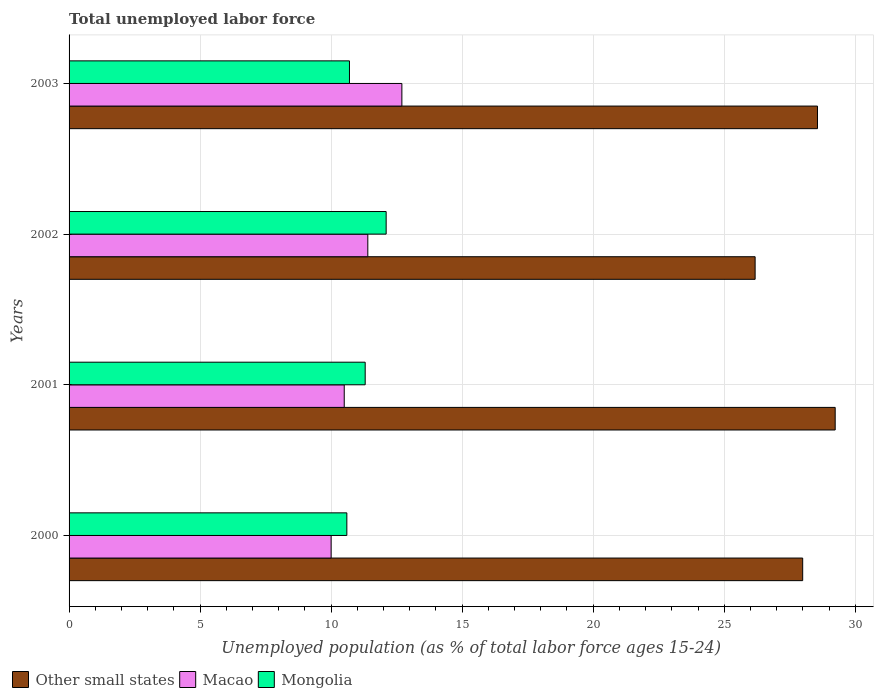Are the number of bars per tick equal to the number of legend labels?
Provide a short and direct response. Yes. Are the number of bars on each tick of the Y-axis equal?
Keep it short and to the point. Yes. How many bars are there on the 1st tick from the bottom?
Make the answer very short. 3. In how many cases, is the number of bars for a given year not equal to the number of legend labels?
Your answer should be very brief. 0. Across all years, what is the maximum percentage of unemployed population in in Other small states?
Your response must be concise. 29.23. Across all years, what is the minimum percentage of unemployed population in in Other small states?
Ensure brevity in your answer.  26.18. In which year was the percentage of unemployed population in in Mongolia minimum?
Offer a terse response. 2000. What is the total percentage of unemployed population in in Mongolia in the graph?
Give a very brief answer. 44.7. What is the difference between the percentage of unemployed population in in Macao in 2000 and that in 2003?
Provide a succinct answer. -2.7. What is the difference between the percentage of unemployed population in in Mongolia in 2001 and the percentage of unemployed population in in Macao in 2003?
Offer a terse response. -1.4. What is the average percentage of unemployed population in in Mongolia per year?
Provide a succinct answer. 11.18. In the year 2003, what is the difference between the percentage of unemployed population in in Mongolia and percentage of unemployed population in in Macao?
Ensure brevity in your answer.  -2. What is the ratio of the percentage of unemployed population in in Other small states in 2001 to that in 2003?
Ensure brevity in your answer.  1.02. Is the percentage of unemployed population in in Mongolia in 2000 less than that in 2003?
Provide a succinct answer. Yes. Is the difference between the percentage of unemployed population in in Mongolia in 2001 and 2003 greater than the difference between the percentage of unemployed population in in Macao in 2001 and 2003?
Offer a very short reply. Yes. What is the difference between the highest and the second highest percentage of unemployed population in in Macao?
Ensure brevity in your answer.  1.3. What is the difference between the highest and the lowest percentage of unemployed population in in Other small states?
Make the answer very short. 3.06. In how many years, is the percentage of unemployed population in in Other small states greater than the average percentage of unemployed population in in Other small states taken over all years?
Provide a succinct answer. 3. What does the 2nd bar from the top in 2003 represents?
Make the answer very short. Macao. What does the 1st bar from the bottom in 2002 represents?
Make the answer very short. Other small states. Is it the case that in every year, the sum of the percentage of unemployed population in in Mongolia and percentage of unemployed population in in Macao is greater than the percentage of unemployed population in in Other small states?
Provide a short and direct response. No. Where does the legend appear in the graph?
Offer a very short reply. Bottom left. How many legend labels are there?
Your answer should be compact. 3. What is the title of the graph?
Provide a succinct answer. Total unemployed labor force. Does "Australia" appear as one of the legend labels in the graph?
Ensure brevity in your answer.  No. What is the label or title of the X-axis?
Offer a very short reply. Unemployed population (as % of total labor force ages 15-24). What is the label or title of the Y-axis?
Your response must be concise. Years. What is the Unemployed population (as % of total labor force ages 15-24) in Other small states in 2000?
Your answer should be compact. 27.99. What is the Unemployed population (as % of total labor force ages 15-24) of Mongolia in 2000?
Offer a terse response. 10.6. What is the Unemployed population (as % of total labor force ages 15-24) of Other small states in 2001?
Give a very brief answer. 29.23. What is the Unemployed population (as % of total labor force ages 15-24) of Macao in 2001?
Your answer should be very brief. 10.5. What is the Unemployed population (as % of total labor force ages 15-24) of Mongolia in 2001?
Ensure brevity in your answer.  11.3. What is the Unemployed population (as % of total labor force ages 15-24) of Other small states in 2002?
Provide a succinct answer. 26.18. What is the Unemployed population (as % of total labor force ages 15-24) in Macao in 2002?
Ensure brevity in your answer.  11.4. What is the Unemployed population (as % of total labor force ages 15-24) in Mongolia in 2002?
Provide a succinct answer. 12.1. What is the Unemployed population (as % of total labor force ages 15-24) in Other small states in 2003?
Give a very brief answer. 28.56. What is the Unemployed population (as % of total labor force ages 15-24) of Macao in 2003?
Ensure brevity in your answer.  12.7. What is the Unemployed population (as % of total labor force ages 15-24) of Mongolia in 2003?
Your answer should be compact. 10.7. Across all years, what is the maximum Unemployed population (as % of total labor force ages 15-24) of Other small states?
Provide a succinct answer. 29.23. Across all years, what is the maximum Unemployed population (as % of total labor force ages 15-24) of Macao?
Your answer should be compact. 12.7. Across all years, what is the maximum Unemployed population (as % of total labor force ages 15-24) of Mongolia?
Provide a succinct answer. 12.1. Across all years, what is the minimum Unemployed population (as % of total labor force ages 15-24) of Other small states?
Ensure brevity in your answer.  26.18. Across all years, what is the minimum Unemployed population (as % of total labor force ages 15-24) in Mongolia?
Offer a terse response. 10.6. What is the total Unemployed population (as % of total labor force ages 15-24) in Other small states in the graph?
Ensure brevity in your answer.  111.97. What is the total Unemployed population (as % of total labor force ages 15-24) of Macao in the graph?
Make the answer very short. 44.6. What is the total Unemployed population (as % of total labor force ages 15-24) of Mongolia in the graph?
Offer a terse response. 44.7. What is the difference between the Unemployed population (as % of total labor force ages 15-24) of Other small states in 2000 and that in 2001?
Your answer should be very brief. -1.24. What is the difference between the Unemployed population (as % of total labor force ages 15-24) of Mongolia in 2000 and that in 2001?
Your answer should be very brief. -0.7. What is the difference between the Unemployed population (as % of total labor force ages 15-24) in Other small states in 2000 and that in 2002?
Offer a very short reply. 1.81. What is the difference between the Unemployed population (as % of total labor force ages 15-24) in Mongolia in 2000 and that in 2002?
Your response must be concise. -1.5. What is the difference between the Unemployed population (as % of total labor force ages 15-24) in Other small states in 2000 and that in 2003?
Ensure brevity in your answer.  -0.56. What is the difference between the Unemployed population (as % of total labor force ages 15-24) in Mongolia in 2000 and that in 2003?
Give a very brief answer. -0.1. What is the difference between the Unemployed population (as % of total labor force ages 15-24) in Other small states in 2001 and that in 2002?
Provide a succinct answer. 3.06. What is the difference between the Unemployed population (as % of total labor force ages 15-24) of Mongolia in 2001 and that in 2002?
Offer a terse response. -0.8. What is the difference between the Unemployed population (as % of total labor force ages 15-24) of Other small states in 2001 and that in 2003?
Give a very brief answer. 0.68. What is the difference between the Unemployed population (as % of total labor force ages 15-24) of Macao in 2001 and that in 2003?
Provide a short and direct response. -2.2. What is the difference between the Unemployed population (as % of total labor force ages 15-24) in Other small states in 2002 and that in 2003?
Your answer should be compact. -2.38. What is the difference between the Unemployed population (as % of total labor force ages 15-24) of Other small states in 2000 and the Unemployed population (as % of total labor force ages 15-24) of Macao in 2001?
Provide a succinct answer. 17.49. What is the difference between the Unemployed population (as % of total labor force ages 15-24) in Other small states in 2000 and the Unemployed population (as % of total labor force ages 15-24) in Mongolia in 2001?
Give a very brief answer. 16.69. What is the difference between the Unemployed population (as % of total labor force ages 15-24) in Other small states in 2000 and the Unemployed population (as % of total labor force ages 15-24) in Macao in 2002?
Your response must be concise. 16.59. What is the difference between the Unemployed population (as % of total labor force ages 15-24) of Other small states in 2000 and the Unemployed population (as % of total labor force ages 15-24) of Mongolia in 2002?
Provide a succinct answer. 15.89. What is the difference between the Unemployed population (as % of total labor force ages 15-24) of Other small states in 2000 and the Unemployed population (as % of total labor force ages 15-24) of Macao in 2003?
Your response must be concise. 15.29. What is the difference between the Unemployed population (as % of total labor force ages 15-24) of Other small states in 2000 and the Unemployed population (as % of total labor force ages 15-24) of Mongolia in 2003?
Provide a short and direct response. 17.29. What is the difference between the Unemployed population (as % of total labor force ages 15-24) in Macao in 2000 and the Unemployed population (as % of total labor force ages 15-24) in Mongolia in 2003?
Your answer should be very brief. -0.7. What is the difference between the Unemployed population (as % of total labor force ages 15-24) of Other small states in 2001 and the Unemployed population (as % of total labor force ages 15-24) of Macao in 2002?
Provide a succinct answer. 17.83. What is the difference between the Unemployed population (as % of total labor force ages 15-24) of Other small states in 2001 and the Unemployed population (as % of total labor force ages 15-24) of Mongolia in 2002?
Provide a short and direct response. 17.13. What is the difference between the Unemployed population (as % of total labor force ages 15-24) in Macao in 2001 and the Unemployed population (as % of total labor force ages 15-24) in Mongolia in 2002?
Offer a terse response. -1.6. What is the difference between the Unemployed population (as % of total labor force ages 15-24) of Other small states in 2001 and the Unemployed population (as % of total labor force ages 15-24) of Macao in 2003?
Ensure brevity in your answer.  16.53. What is the difference between the Unemployed population (as % of total labor force ages 15-24) of Other small states in 2001 and the Unemployed population (as % of total labor force ages 15-24) of Mongolia in 2003?
Keep it short and to the point. 18.53. What is the difference between the Unemployed population (as % of total labor force ages 15-24) of Macao in 2001 and the Unemployed population (as % of total labor force ages 15-24) of Mongolia in 2003?
Give a very brief answer. -0.2. What is the difference between the Unemployed population (as % of total labor force ages 15-24) of Other small states in 2002 and the Unemployed population (as % of total labor force ages 15-24) of Macao in 2003?
Provide a succinct answer. 13.48. What is the difference between the Unemployed population (as % of total labor force ages 15-24) in Other small states in 2002 and the Unemployed population (as % of total labor force ages 15-24) in Mongolia in 2003?
Make the answer very short. 15.48. What is the difference between the Unemployed population (as % of total labor force ages 15-24) of Macao in 2002 and the Unemployed population (as % of total labor force ages 15-24) of Mongolia in 2003?
Provide a succinct answer. 0.7. What is the average Unemployed population (as % of total labor force ages 15-24) in Other small states per year?
Offer a terse response. 27.99. What is the average Unemployed population (as % of total labor force ages 15-24) of Macao per year?
Offer a very short reply. 11.15. What is the average Unemployed population (as % of total labor force ages 15-24) of Mongolia per year?
Keep it short and to the point. 11.18. In the year 2000, what is the difference between the Unemployed population (as % of total labor force ages 15-24) in Other small states and Unemployed population (as % of total labor force ages 15-24) in Macao?
Provide a succinct answer. 17.99. In the year 2000, what is the difference between the Unemployed population (as % of total labor force ages 15-24) in Other small states and Unemployed population (as % of total labor force ages 15-24) in Mongolia?
Provide a short and direct response. 17.39. In the year 2001, what is the difference between the Unemployed population (as % of total labor force ages 15-24) in Other small states and Unemployed population (as % of total labor force ages 15-24) in Macao?
Provide a short and direct response. 18.73. In the year 2001, what is the difference between the Unemployed population (as % of total labor force ages 15-24) in Other small states and Unemployed population (as % of total labor force ages 15-24) in Mongolia?
Your response must be concise. 17.93. In the year 2002, what is the difference between the Unemployed population (as % of total labor force ages 15-24) of Other small states and Unemployed population (as % of total labor force ages 15-24) of Macao?
Make the answer very short. 14.78. In the year 2002, what is the difference between the Unemployed population (as % of total labor force ages 15-24) in Other small states and Unemployed population (as % of total labor force ages 15-24) in Mongolia?
Give a very brief answer. 14.08. In the year 2002, what is the difference between the Unemployed population (as % of total labor force ages 15-24) in Macao and Unemployed population (as % of total labor force ages 15-24) in Mongolia?
Ensure brevity in your answer.  -0.7. In the year 2003, what is the difference between the Unemployed population (as % of total labor force ages 15-24) in Other small states and Unemployed population (as % of total labor force ages 15-24) in Macao?
Ensure brevity in your answer.  15.86. In the year 2003, what is the difference between the Unemployed population (as % of total labor force ages 15-24) of Other small states and Unemployed population (as % of total labor force ages 15-24) of Mongolia?
Give a very brief answer. 17.86. What is the ratio of the Unemployed population (as % of total labor force ages 15-24) of Other small states in 2000 to that in 2001?
Provide a short and direct response. 0.96. What is the ratio of the Unemployed population (as % of total labor force ages 15-24) in Macao in 2000 to that in 2001?
Give a very brief answer. 0.95. What is the ratio of the Unemployed population (as % of total labor force ages 15-24) of Mongolia in 2000 to that in 2001?
Give a very brief answer. 0.94. What is the ratio of the Unemployed population (as % of total labor force ages 15-24) of Other small states in 2000 to that in 2002?
Ensure brevity in your answer.  1.07. What is the ratio of the Unemployed population (as % of total labor force ages 15-24) of Macao in 2000 to that in 2002?
Your response must be concise. 0.88. What is the ratio of the Unemployed population (as % of total labor force ages 15-24) of Mongolia in 2000 to that in 2002?
Your answer should be very brief. 0.88. What is the ratio of the Unemployed population (as % of total labor force ages 15-24) in Other small states in 2000 to that in 2003?
Your answer should be very brief. 0.98. What is the ratio of the Unemployed population (as % of total labor force ages 15-24) in Macao in 2000 to that in 2003?
Your answer should be very brief. 0.79. What is the ratio of the Unemployed population (as % of total labor force ages 15-24) in Other small states in 2001 to that in 2002?
Your answer should be compact. 1.12. What is the ratio of the Unemployed population (as % of total labor force ages 15-24) in Macao in 2001 to that in 2002?
Make the answer very short. 0.92. What is the ratio of the Unemployed population (as % of total labor force ages 15-24) in Mongolia in 2001 to that in 2002?
Give a very brief answer. 0.93. What is the ratio of the Unemployed population (as % of total labor force ages 15-24) in Other small states in 2001 to that in 2003?
Your response must be concise. 1.02. What is the ratio of the Unemployed population (as % of total labor force ages 15-24) in Macao in 2001 to that in 2003?
Your answer should be compact. 0.83. What is the ratio of the Unemployed population (as % of total labor force ages 15-24) in Mongolia in 2001 to that in 2003?
Provide a succinct answer. 1.06. What is the ratio of the Unemployed population (as % of total labor force ages 15-24) of Other small states in 2002 to that in 2003?
Provide a short and direct response. 0.92. What is the ratio of the Unemployed population (as % of total labor force ages 15-24) of Macao in 2002 to that in 2003?
Your answer should be very brief. 0.9. What is the ratio of the Unemployed population (as % of total labor force ages 15-24) of Mongolia in 2002 to that in 2003?
Offer a terse response. 1.13. What is the difference between the highest and the second highest Unemployed population (as % of total labor force ages 15-24) of Other small states?
Offer a terse response. 0.68. What is the difference between the highest and the second highest Unemployed population (as % of total labor force ages 15-24) in Macao?
Your answer should be compact. 1.3. What is the difference between the highest and the lowest Unemployed population (as % of total labor force ages 15-24) in Other small states?
Ensure brevity in your answer.  3.06. 